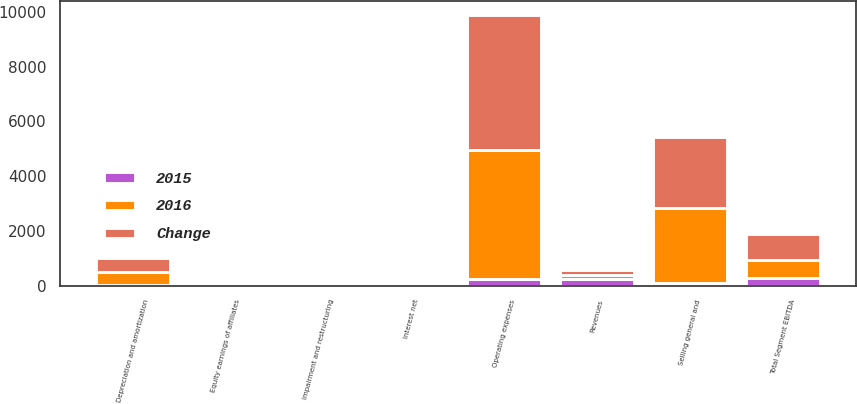Convert chart. <chart><loc_0><loc_0><loc_500><loc_500><stacked_bar_chart><ecel><fcel>Revenues<fcel>Operating expenses<fcel>Selling general and<fcel>Total Segment EBITDA<fcel>Depreciation and amortization<fcel>Impairment and restructuring<fcel>Equity earnings of affiliates<fcel>Interest net<nl><fcel>2016<fcel>159.5<fcel>4728<fcel>2722<fcel>684<fcel>505<fcel>89<fcel>30<fcel>43<nl><fcel>Change<fcel>159.5<fcel>4952<fcel>2627<fcel>945<fcel>498<fcel>84<fcel>58<fcel>56<nl><fcel>2015<fcel>232<fcel>224<fcel>95<fcel>261<fcel>7<fcel>5<fcel>28<fcel>13<nl></chart> 